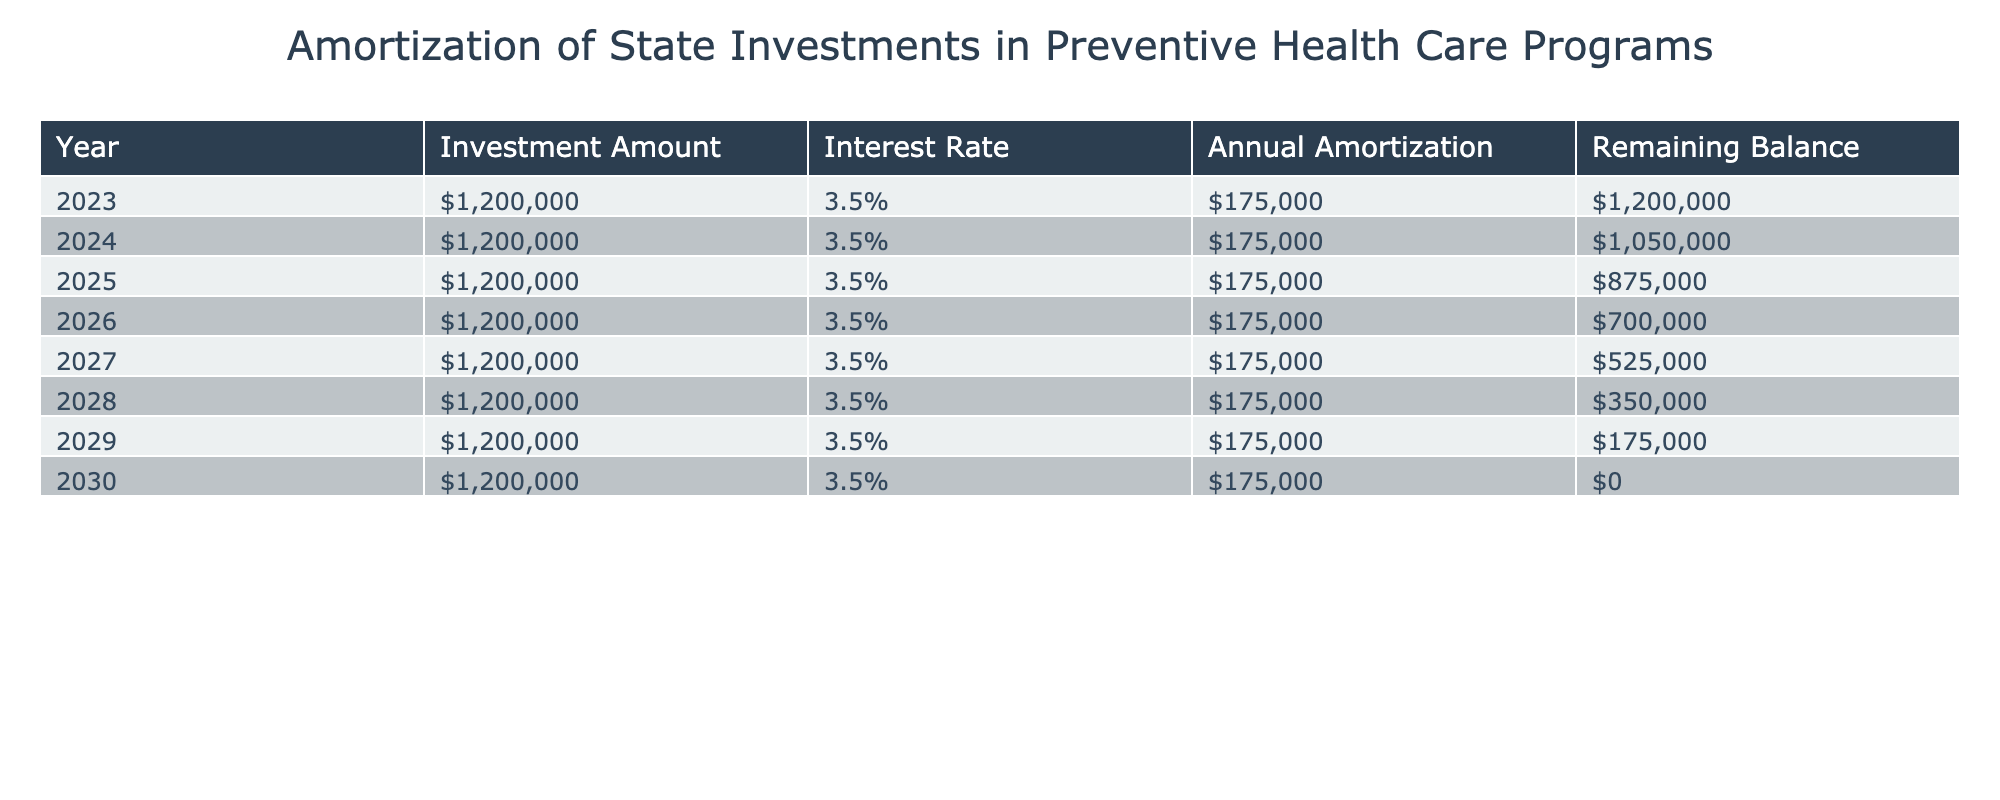What is the total investment amount made in preventive health care programs over the years? The investment amount is consistent at 1,200,000 for each of the 8 years from 2023 to 2030. To find the total investment, multiply the annual investment by the number of years: 1,200,000 * 8 = 9,600,000.
Answer: 9,600,000 In which year does the remaining balance first reach zero? The remaining balance reaches zero in 2030, as indicated in that year's row where the remaining balance is listed as $0.
Answer: 2030 What is the annual amortization amount for each year? The annual amortization amount remains constant at 175,000 for each year, as shown in all rows of the table.
Answer: 175,000 Is the interest rate for state investments in preventive health care programs the same each year? Yes, the interest rate is consistently 3.5% for every year from 2023 to 2030, as reflected in the table.
Answer: Yes How much is the remaining balance reduced after the first four years of amortization? The remaining balance decreases from 1,200,000 in 2023 to 700,000 in 2026. The reduction is calculated as: 1,200,000 - 700,000 = 500,000.
Answer: 500,000 What is the average remaining balance over the entire duration of the investment? To find the average remaining balance, sum all the remaining balances for each year and divide by the number of years: (1,200,000 + 1,050,000 + 875,000 + 700,000 + 525,000 + 350,000 + 175,000 + 0) / 8 = 525,000.
Answer: 525,000 How much is the remaining balance after 5 years? After 5 years, the remaining balance is 525,000, as indicated in the corresponding row for the year 2027.
Answer: 525,000 What was the initial remaining balance when the program began? The initial remaining balance at the start of the program in 2023 is 1,200,000, as stated in the first row of the table.
Answer: 1,200,000 